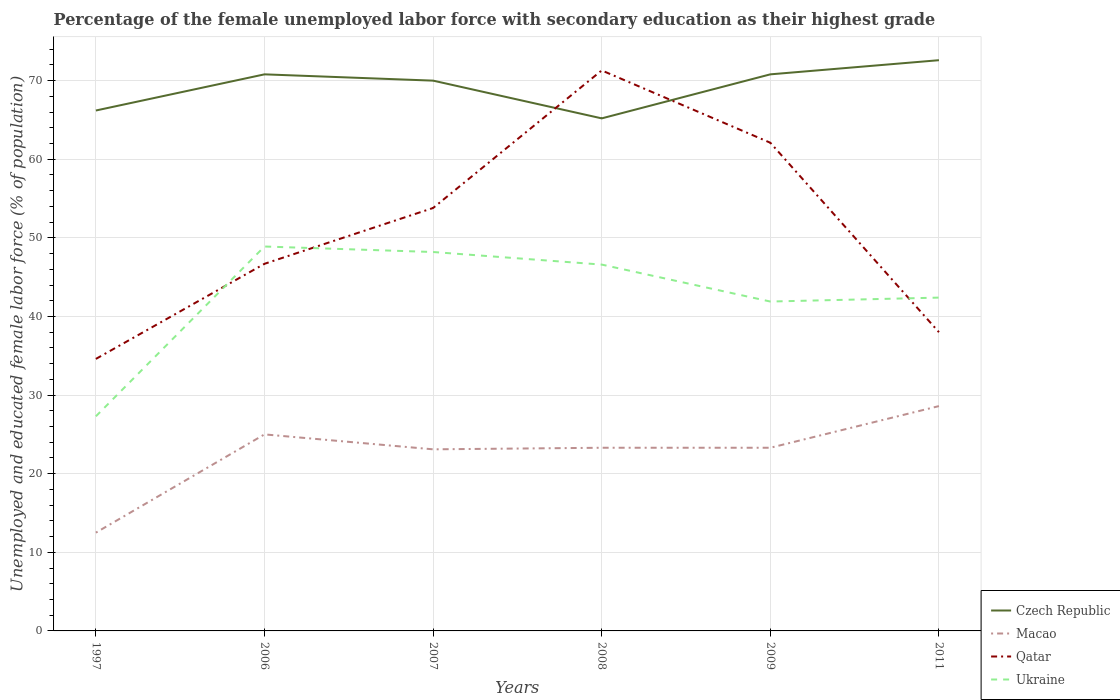In which year was the percentage of the unemployed female labor force with secondary education in Qatar maximum?
Ensure brevity in your answer.  1997. What is the total percentage of the unemployed female labor force with secondary education in Macao in the graph?
Ensure brevity in your answer.  -10.8. What is the difference between the highest and the second highest percentage of the unemployed female labor force with secondary education in Czech Republic?
Provide a short and direct response. 7.4. How many years are there in the graph?
Ensure brevity in your answer.  6. What is the difference between two consecutive major ticks on the Y-axis?
Your answer should be compact. 10. Does the graph contain any zero values?
Offer a very short reply. No. Does the graph contain grids?
Ensure brevity in your answer.  Yes. How many legend labels are there?
Offer a terse response. 4. How are the legend labels stacked?
Make the answer very short. Vertical. What is the title of the graph?
Offer a very short reply. Percentage of the female unemployed labor force with secondary education as their highest grade. Does "Arab World" appear as one of the legend labels in the graph?
Offer a terse response. No. What is the label or title of the X-axis?
Ensure brevity in your answer.  Years. What is the label or title of the Y-axis?
Ensure brevity in your answer.  Unemployed and educated female labor force (% of population). What is the Unemployed and educated female labor force (% of population) of Czech Republic in 1997?
Offer a very short reply. 66.2. What is the Unemployed and educated female labor force (% of population) in Qatar in 1997?
Ensure brevity in your answer.  34.6. What is the Unemployed and educated female labor force (% of population) of Ukraine in 1997?
Provide a short and direct response. 27.3. What is the Unemployed and educated female labor force (% of population) of Czech Republic in 2006?
Provide a short and direct response. 70.8. What is the Unemployed and educated female labor force (% of population) of Macao in 2006?
Provide a short and direct response. 25. What is the Unemployed and educated female labor force (% of population) in Qatar in 2006?
Make the answer very short. 46.7. What is the Unemployed and educated female labor force (% of population) of Ukraine in 2006?
Make the answer very short. 48.9. What is the Unemployed and educated female labor force (% of population) of Czech Republic in 2007?
Give a very brief answer. 70. What is the Unemployed and educated female labor force (% of population) in Macao in 2007?
Give a very brief answer. 23.1. What is the Unemployed and educated female labor force (% of population) of Qatar in 2007?
Your answer should be very brief. 53.8. What is the Unemployed and educated female labor force (% of population) in Ukraine in 2007?
Provide a short and direct response. 48.2. What is the Unemployed and educated female labor force (% of population) in Czech Republic in 2008?
Your response must be concise. 65.2. What is the Unemployed and educated female labor force (% of population) of Macao in 2008?
Offer a very short reply. 23.3. What is the Unemployed and educated female labor force (% of population) in Qatar in 2008?
Give a very brief answer. 71.3. What is the Unemployed and educated female labor force (% of population) in Ukraine in 2008?
Your answer should be compact. 46.6. What is the Unemployed and educated female labor force (% of population) in Czech Republic in 2009?
Provide a succinct answer. 70.8. What is the Unemployed and educated female labor force (% of population) of Macao in 2009?
Provide a succinct answer. 23.3. What is the Unemployed and educated female labor force (% of population) of Qatar in 2009?
Your answer should be compact. 62.1. What is the Unemployed and educated female labor force (% of population) in Ukraine in 2009?
Your answer should be very brief. 41.9. What is the Unemployed and educated female labor force (% of population) of Czech Republic in 2011?
Provide a short and direct response. 72.6. What is the Unemployed and educated female labor force (% of population) of Macao in 2011?
Offer a terse response. 28.6. What is the Unemployed and educated female labor force (% of population) of Ukraine in 2011?
Make the answer very short. 42.4. Across all years, what is the maximum Unemployed and educated female labor force (% of population) of Czech Republic?
Make the answer very short. 72.6. Across all years, what is the maximum Unemployed and educated female labor force (% of population) in Macao?
Offer a terse response. 28.6. Across all years, what is the maximum Unemployed and educated female labor force (% of population) of Qatar?
Ensure brevity in your answer.  71.3. Across all years, what is the maximum Unemployed and educated female labor force (% of population) in Ukraine?
Ensure brevity in your answer.  48.9. Across all years, what is the minimum Unemployed and educated female labor force (% of population) of Czech Republic?
Give a very brief answer. 65.2. Across all years, what is the minimum Unemployed and educated female labor force (% of population) of Qatar?
Give a very brief answer. 34.6. Across all years, what is the minimum Unemployed and educated female labor force (% of population) in Ukraine?
Keep it short and to the point. 27.3. What is the total Unemployed and educated female labor force (% of population) of Czech Republic in the graph?
Provide a succinct answer. 415.6. What is the total Unemployed and educated female labor force (% of population) in Macao in the graph?
Make the answer very short. 135.8. What is the total Unemployed and educated female labor force (% of population) in Qatar in the graph?
Keep it short and to the point. 306.5. What is the total Unemployed and educated female labor force (% of population) of Ukraine in the graph?
Your answer should be compact. 255.3. What is the difference between the Unemployed and educated female labor force (% of population) in Czech Republic in 1997 and that in 2006?
Your answer should be very brief. -4.6. What is the difference between the Unemployed and educated female labor force (% of population) of Macao in 1997 and that in 2006?
Offer a very short reply. -12.5. What is the difference between the Unemployed and educated female labor force (% of population) of Ukraine in 1997 and that in 2006?
Your answer should be compact. -21.6. What is the difference between the Unemployed and educated female labor force (% of population) in Qatar in 1997 and that in 2007?
Provide a succinct answer. -19.2. What is the difference between the Unemployed and educated female labor force (% of population) in Ukraine in 1997 and that in 2007?
Provide a short and direct response. -20.9. What is the difference between the Unemployed and educated female labor force (% of population) in Qatar in 1997 and that in 2008?
Your response must be concise. -36.7. What is the difference between the Unemployed and educated female labor force (% of population) in Ukraine in 1997 and that in 2008?
Give a very brief answer. -19.3. What is the difference between the Unemployed and educated female labor force (% of population) in Macao in 1997 and that in 2009?
Provide a short and direct response. -10.8. What is the difference between the Unemployed and educated female labor force (% of population) in Qatar in 1997 and that in 2009?
Your answer should be compact. -27.5. What is the difference between the Unemployed and educated female labor force (% of population) of Ukraine in 1997 and that in 2009?
Your answer should be very brief. -14.6. What is the difference between the Unemployed and educated female labor force (% of population) in Macao in 1997 and that in 2011?
Provide a short and direct response. -16.1. What is the difference between the Unemployed and educated female labor force (% of population) of Qatar in 1997 and that in 2011?
Keep it short and to the point. -3.4. What is the difference between the Unemployed and educated female labor force (% of population) in Ukraine in 1997 and that in 2011?
Offer a very short reply. -15.1. What is the difference between the Unemployed and educated female labor force (% of population) of Qatar in 2006 and that in 2007?
Your answer should be very brief. -7.1. What is the difference between the Unemployed and educated female labor force (% of population) in Macao in 2006 and that in 2008?
Your response must be concise. 1.7. What is the difference between the Unemployed and educated female labor force (% of population) of Qatar in 2006 and that in 2008?
Keep it short and to the point. -24.6. What is the difference between the Unemployed and educated female labor force (% of population) of Ukraine in 2006 and that in 2008?
Ensure brevity in your answer.  2.3. What is the difference between the Unemployed and educated female labor force (% of population) of Qatar in 2006 and that in 2009?
Offer a terse response. -15.4. What is the difference between the Unemployed and educated female labor force (% of population) in Ukraine in 2006 and that in 2011?
Your answer should be compact. 6.5. What is the difference between the Unemployed and educated female labor force (% of population) in Macao in 2007 and that in 2008?
Keep it short and to the point. -0.2. What is the difference between the Unemployed and educated female labor force (% of population) in Qatar in 2007 and that in 2008?
Provide a short and direct response. -17.5. What is the difference between the Unemployed and educated female labor force (% of population) of Macao in 2007 and that in 2011?
Offer a terse response. -5.5. What is the difference between the Unemployed and educated female labor force (% of population) of Ukraine in 2008 and that in 2009?
Ensure brevity in your answer.  4.7. What is the difference between the Unemployed and educated female labor force (% of population) of Czech Republic in 2008 and that in 2011?
Your answer should be compact. -7.4. What is the difference between the Unemployed and educated female labor force (% of population) in Macao in 2008 and that in 2011?
Keep it short and to the point. -5.3. What is the difference between the Unemployed and educated female labor force (% of population) of Qatar in 2008 and that in 2011?
Provide a short and direct response. 33.3. What is the difference between the Unemployed and educated female labor force (% of population) in Ukraine in 2008 and that in 2011?
Your response must be concise. 4.2. What is the difference between the Unemployed and educated female labor force (% of population) of Qatar in 2009 and that in 2011?
Offer a terse response. 24.1. What is the difference between the Unemployed and educated female labor force (% of population) of Czech Republic in 1997 and the Unemployed and educated female labor force (% of population) of Macao in 2006?
Ensure brevity in your answer.  41.2. What is the difference between the Unemployed and educated female labor force (% of population) of Czech Republic in 1997 and the Unemployed and educated female labor force (% of population) of Qatar in 2006?
Make the answer very short. 19.5. What is the difference between the Unemployed and educated female labor force (% of population) of Macao in 1997 and the Unemployed and educated female labor force (% of population) of Qatar in 2006?
Give a very brief answer. -34.2. What is the difference between the Unemployed and educated female labor force (% of population) in Macao in 1997 and the Unemployed and educated female labor force (% of population) in Ukraine in 2006?
Your response must be concise. -36.4. What is the difference between the Unemployed and educated female labor force (% of population) of Qatar in 1997 and the Unemployed and educated female labor force (% of population) of Ukraine in 2006?
Offer a terse response. -14.3. What is the difference between the Unemployed and educated female labor force (% of population) in Czech Republic in 1997 and the Unemployed and educated female labor force (% of population) in Macao in 2007?
Provide a succinct answer. 43.1. What is the difference between the Unemployed and educated female labor force (% of population) in Czech Republic in 1997 and the Unemployed and educated female labor force (% of population) in Ukraine in 2007?
Keep it short and to the point. 18. What is the difference between the Unemployed and educated female labor force (% of population) of Macao in 1997 and the Unemployed and educated female labor force (% of population) of Qatar in 2007?
Ensure brevity in your answer.  -41.3. What is the difference between the Unemployed and educated female labor force (% of population) in Macao in 1997 and the Unemployed and educated female labor force (% of population) in Ukraine in 2007?
Your answer should be very brief. -35.7. What is the difference between the Unemployed and educated female labor force (% of population) of Czech Republic in 1997 and the Unemployed and educated female labor force (% of population) of Macao in 2008?
Provide a succinct answer. 42.9. What is the difference between the Unemployed and educated female labor force (% of population) of Czech Republic in 1997 and the Unemployed and educated female labor force (% of population) of Qatar in 2008?
Provide a succinct answer. -5.1. What is the difference between the Unemployed and educated female labor force (% of population) of Czech Republic in 1997 and the Unemployed and educated female labor force (% of population) of Ukraine in 2008?
Offer a very short reply. 19.6. What is the difference between the Unemployed and educated female labor force (% of population) of Macao in 1997 and the Unemployed and educated female labor force (% of population) of Qatar in 2008?
Your answer should be very brief. -58.8. What is the difference between the Unemployed and educated female labor force (% of population) in Macao in 1997 and the Unemployed and educated female labor force (% of population) in Ukraine in 2008?
Your answer should be very brief. -34.1. What is the difference between the Unemployed and educated female labor force (% of population) in Czech Republic in 1997 and the Unemployed and educated female labor force (% of population) in Macao in 2009?
Offer a terse response. 42.9. What is the difference between the Unemployed and educated female labor force (% of population) in Czech Republic in 1997 and the Unemployed and educated female labor force (% of population) in Qatar in 2009?
Keep it short and to the point. 4.1. What is the difference between the Unemployed and educated female labor force (% of population) in Czech Republic in 1997 and the Unemployed and educated female labor force (% of population) in Ukraine in 2009?
Provide a short and direct response. 24.3. What is the difference between the Unemployed and educated female labor force (% of population) in Macao in 1997 and the Unemployed and educated female labor force (% of population) in Qatar in 2009?
Ensure brevity in your answer.  -49.6. What is the difference between the Unemployed and educated female labor force (% of population) in Macao in 1997 and the Unemployed and educated female labor force (% of population) in Ukraine in 2009?
Your answer should be very brief. -29.4. What is the difference between the Unemployed and educated female labor force (% of population) in Qatar in 1997 and the Unemployed and educated female labor force (% of population) in Ukraine in 2009?
Offer a terse response. -7.3. What is the difference between the Unemployed and educated female labor force (% of population) of Czech Republic in 1997 and the Unemployed and educated female labor force (% of population) of Macao in 2011?
Offer a terse response. 37.6. What is the difference between the Unemployed and educated female labor force (% of population) of Czech Republic in 1997 and the Unemployed and educated female labor force (% of population) of Qatar in 2011?
Offer a very short reply. 28.2. What is the difference between the Unemployed and educated female labor force (% of population) in Czech Republic in 1997 and the Unemployed and educated female labor force (% of population) in Ukraine in 2011?
Offer a terse response. 23.8. What is the difference between the Unemployed and educated female labor force (% of population) of Macao in 1997 and the Unemployed and educated female labor force (% of population) of Qatar in 2011?
Provide a succinct answer. -25.5. What is the difference between the Unemployed and educated female labor force (% of population) in Macao in 1997 and the Unemployed and educated female labor force (% of population) in Ukraine in 2011?
Offer a very short reply. -29.9. What is the difference between the Unemployed and educated female labor force (% of population) of Czech Republic in 2006 and the Unemployed and educated female labor force (% of population) of Macao in 2007?
Keep it short and to the point. 47.7. What is the difference between the Unemployed and educated female labor force (% of population) in Czech Republic in 2006 and the Unemployed and educated female labor force (% of population) in Qatar in 2007?
Ensure brevity in your answer.  17. What is the difference between the Unemployed and educated female labor force (% of population) in Czech Republic in 2006 and the Unemployed and educated female labor force (% of population) in Ukraine in 2007?
Offer a terse response. 22.6. What is the difference between the Unemployed and educated female labor force (% of population) of Macao in 2006 and the Unemployed and educated female labor force (% of population) of Qatar in 2007?
Provide a succinct answer. -28.8. What is the difference between the Unemployed and educated female labor force (% of population) of Macao in 2006 and the Unemployed and educated female labor force (% of population) of Ukraine in 2007?
Your answer should be compact. -23.2. What is the difference between the Unemployed and educated female labor force (% of population) in Qatar in 2006 and the Unemployed and educated female labor force (% of population) in Ukraine in 2007?
Ensure brevity in your answer.  -1.5. What is the difference between the Unemployed and educated female labor force (% of population) in Czech Republic in 2006 and the Unemployed and educated female labor force (% of population) in Macao in 2008?
Your answer should be compact. 47.5. What is the difference between the Unemployed and educated female labor force (% of population) in Czech Republic in 2006 and the Unemployed and educated female labor force (% of population) in Qatar in 2008?
Offer a very short reply. -0.5. What is the difference between the Unemployed and educated female labor force (% of population) in Czech Republic in 2006 and the Unemployed and educated female labor force (% of population) in Ukraine in 2008?
Ensure brevity in your answer.  24.2. What is the difference between the Unemployed and educated female labor force (% of population) of Macao in 2006 and the Unemployed and educated female labor force (% of population) of Qatar in 2008?
Offer a terse response. -46.3. What is the difference between the Unemployed and educated female labor force (% of population) of Macao in 2006 and the Unemployed and educated female labor force (% of population) of Ukraine in 2008?
Offer a terse response. -21.6. What is the difference between the Unemployed and educated female labor force (% of population) in Czech Republic in 2006 and the Unemployed and educated female labor force (% of population) in Macao in 2009?
Offer a very short reply. 47.5. What is the difference between the Unemployed and educated female labor force (% of population) of Czech Republic in 2006 and the Unemployed and educated female labor force (% of population) of Qatar in 2009?
Your response must be concise. 8.7. What is the difference between the Unemployed and educated female labor force (% of population) of Czech Republic in 2006 and the Unemployed and educated female labor force (% of population) of Ukraine in 2009?
Give a very brief answer. 28.9. What is the difference between the Unemployed and educated female labor force (% of population) in Macao in 2006 and the Unemployed and educated female labor force (% of population) in Qatar in 2009?
Provide a succinct answer. -37.1. What is the difference between the Unemployed and educated female labor force (% of population) in Macao in 2006 and the Unemployed and educated female labor force (% of population) in Ukraine in 2009?
Make the answer very short. -16.9. What is the difference between the Unemployed and educated female labor force (% of population) of Czech Republic in 2006 and the Unemployed and educated female labor force (% of population) of Macao in 2011?
Your answer should be compact. 42.2. What is the difference between the Unemployed and educated female labor force (% of population) in Czech Republic in 2006 and the Unemployed and educated female labor force (% of population) in Qatar in 2011?
Keep it short and to the point. 32.8. What is the difference between the Unemployed and educated female labor force (% of population) of Czech Republic in 2006 and the Unemployed and educated female labor force (% of population) of Ukraine in 2011?
Offer a terse response. 28.4. What is the difference between the Unemployed and educated female labor force (% of population) of Macao in 2006 and the Unemployed and educated female labor force (% of population) of Ukraine in 2011?
Make the answer very short. -17.4. What is the difference between the Unemployed and educated female labor force (% of population) in Qatar in 2006 and the Unemployed and educated female labor force (% of population) in Ukraine in 2011?
Your answer should be compact. 4.3. What is the difference between the Unemployed and educated female labor force (% of population) of Czech Republic in 2007 and the Unemployed and educated female labor force (% of population) of Macao in 2008?
Your answer should be very brief. 46.7. What is the difference between the Unemployed and educated female labor force (% of population) in Czech Republic in 2007 and the Unemployed and educated female labor force (% of population) in Ukraine in 2008?
Provide a short and direct response. 23.4. What is the difference between the Unemployed and educated female labor force (% of population) of Macao in 2007 and the Unemployed and educated female labor force (% of population) of Qatar in 2008?
Your response must be concise. -48.2. What is the difference between the Unemployed and educated female labor force (% of population) in Macao in 2007 and the Unemployed and educated female labor force (% of population) in Ukraine in 2008?
Your answer should be compact. -23.5. What is the difference between the Unemployed and educated female labor force (% of population) of Czech Republic in 2007 and the Unemployed and educated female labor force (% of population) of Macao in 2009?
Your response must be concise. 46.7. What is the difference between the Unemployed and educated female labor force (% of population) of Czech Republic in 2007 and the Unemployed and educated female labor force (% of population) of Qatar in 2009?
Ensure brevity in your answer.  7.9. What is the difference between the Unemployed and educated female labor force (% of population) in Czech Republic in 2007 and the Unemployed and educated female labor force (% of population) in Ukraine in 2009?
Make the answer very short. 28.1. What is the difference between the Unemployed and educated female labor force (% of population) of Macao in 2007 and the Unemployed and educated female labor force (% of population) of Qatar in 2009?
Offer a terse response. -39. What is the difference between the Unemployed and educated female labor force (% of population) of Macao in 2007 and the Unemployed and educated female labor force (% of population) of Ukraine in 2009?
Offer a very short reply. -18.8. What is the difference between the Unemployed and educated female labor force (% of population) of Czech Republic in 2007 and the Unemployed and educated female labor force (% of population) of Macao in 2011?
Keep it short and to the point. 41.4. What is the difference between the Unemployed and educated female labor force (% of population) of Czech Republic in 2007 and the Unemployed and educated female labor force (% of population) of Ukraine in 2011?
Offer a terse response. 27.6. What is the difference between the Unemployed and educated female labor force (% of population) of Macao in 2007 and the Unemployed and educated female labor force (% of population) of Qatar in 2011?
Give a very brief answer. -14.9. What is the difference between the Unemployed and educated female labor force (% of population) of Macao in 2007 and the Unemployed and educated female labor force (% of population) of Ukraine in 2011?
Keep it short and to the point. -19.3. What is the difference between the Unemployed and educated female labor force (% of population) in Czech Republic in 2008 and the Unemployed and educated female labor force (% of population) in Macao in 2009?
Keep it short and to the point. 41.9. What is the difference between the Unemployed and educated female labor force (% of population) of Czech Republic in 2008 and the Unemployed and educated female labor force (% of population) of Ukraine in 2009?
Your response must be concise. 23.3. What is the difference between the Unemployed and educated female labor force (% of population) of Macao in 2008 and the Unemployed and educated female labor force (% of population) of Qatar in 2009?
Provide a short and direct response. -38.8. What is the difference between the Unemployed and educated female labor force (% of population) in Macao in 2008 and the Unemployed and educated female labor force (% of population) in Ukraine in 2009?
Your response must be concise. -18.6. What is the difference between the Unemployed and educated female labor force (% of population) of Qatar in 2008 and the Unemployed and educated female labor force (% of population) of Ukraine in 2009?
Keep it short and to the point. 29.4. What is the difference between the Unemployed and educated female labor force (% of population) in Czech Republic in 2008 and the Unemployed and educated female labor force (% of population) in Macao in 2011?
Your answer should be compact. 36.6. What is the difference between the Unemployed and educated female labor force (% of population) of Czech Republic in 2008 and the Unemployed and educated female labor force (% of population) of Qatar in 2011?
Provide a short and direct response. 27.2. What is the difference between the Unemployed and educated female labor force (% of population) of Czech Republic in 2008 and the Unemployed and educated female labor force (% of population) of Ukraine in 2011?
Keep it short and to the point. 22.8. What is the difference between the Unemployed and educated female labor force (% of population) of Macao in 2008 and the Unemployed and educated female labor force (% of population) of Qatar in 2011?
Ensure brevity in your answer.  -14.7. What is the difference between the Unemployed and educated female labor force (% of population) of Macao in 2008 and the Unemployed and educated female labor force (% of population) of Ukraine in 2011?
Offer a terse response. -19.1. What is the difference between the Unemployed and educated female labor force (% of population) of Qatar in 2008 and the Unemployed and educated female labor force (% of population) of Ukraine in 2011?
Your response must be concise. 28.9. What is the difference between the Unemployed and educated female labor force (% of population) in Czech Republic in 2009 and the Unemployed and educated female labor force (% of population) in Macao in 2011?
Provide a short and direct response. 42.2. What is the difference between the Unemployed and educated female labor force (% of population) in Czech Republic in 2009 and the Unemployed and educated female labor force (% of population) in Qatar in 2011?
Your answer should be compact. 32.8. What is the difference between the Unemployed and educated female labor force (% of population) in Czech Republic in 2009 and the Unemployed and educated female labor force (% of population) in Ukraine in 2011?
Offer a terse response. 28.4. What is the difference between the Unemployed and educated female labor force (% of population) of Macao in 2009 and the Unemployed and educated female labor force (% of population) of Qatar in 2011?
Keep it short and to the point. -14.7. What is the difference between the Unemployed and educated female labor force (% of population) of Macao in 2009 and the Unemployed and educated female labor force (% of population) of Ukraine in 2011?
Your answer should be very brief. -19.1. What is the average Unemployed and educated female labor force (% of population) in Czech Republic per year?
Your answer should be compact. 69.27. What is the average Unemployed and educated female labor force (% of population) of Macao per year?
Your answer should be very brief. 22.63. What is the average Unemployed and educated female labor force (% of population) of Qatar per year?
Keep it short and to the point. 51.08. What is the average Unemployed and educated female labor force (% of population) of Ukraine per year?
Provide a short and direct response. 42.55. In the year 1997, what is the difference between the Unemployed and educated female labor force (% of population) in Czech Republic and Unemployed and educated female labor force (% of population) in Macao?
Provide a short and direct response. 53.7. In the year 1997, what is the difference between the Unemployed and educated female labor force (% of population) of Czech Republic and Unemployed and educated female labor force (% of population) of Qatar?
Give a very brief answer. 31.6. In the year 1997, what is the difference between the Unemployed and educated female labor force (% of population) of Czech Republic and Unemployed and educated female labor force (% of population) of Ukraine?
Offer a terse response. 38.9. In the year 1997, what is the difference between the Unemployed and educated female labor force (% of population) of Macao and Unemployed and educated female labor force (% of population) of Qatar?
Provide a succinct answer. -22.1. In the year 1997, what is the difference between the Unemployed and educated female labor force (% of population) in Macao and Unemployed and educated female labor force (% of population) in Ukraine?
Provide a succinct answer. -14.8. In the year 2006, what is the difference between the Unemployed and educated female labor force (% of population) in Czech Republic and Unemployed and educated female labor force (% of population) in Macao?
Provide a succinct answer. 45.8. In the year 2006, what is the difference between the Unemployed and educated female labor force (% of population) in Czech Republic and Unemployed and educated female labor force (% of population) in Qatar?
Offer a very short reply. 24.1. In the year 2006, what is the difference between the Unemployed and educated female labor force (% of population) of Czech Republic and Unemployed and educated female labor force (% of population) of Ukraine?
Offer a terse response. 21.9. In the year 2006, what is the difference between the Unemployed and educated female labor force (% of population) in Macao and Unemployed and educated female labor force (% of population) in Qatar?
Your answer should be very brief. -21.7. In the year 2006, what is the difference between the Unemployed and educated female labor force (% of population) in Macao and Unemployed and educated female labor force (% of population) in Ukraine?
Provide a succinct answer. -23.9. In the year 2007, what is the difference between the Unemployed and educated female labor force (% of population) in Czech Republic and Unemployed and educated female labor force (% of population) in Macao?
Provide a short and direct response. 46.9. In the year 2007, what is the difference between the Unemployed and educated female labor force (% of population) in Czech Republic and Unemployed and educated female labor force (% of population) in Ukraine?
Provide a succinct answer. 21.8. In the year 2007, what is the difference between the Unemployed and educated female labor force (% of population) in Macao and Unemployed and educated female labor force (% of population) in Qatar?
Your answer should be compact. -30.7. In the year 2007, what is the difference between the Unemployed and educated female labor force (% of population) of Macao and Unemployed and educated female labor force (% of population) of Ukraine?
Offer a terse response. -25.1. In the year 2008, what is the difference between the Unemployed and educated female labor force (% of population) in Czech Republic and Unemployed and educated female labor force (% of population) in Macao?
Offer a very short reply. 41.9. In the year 2008, what is the difference between the Unemployed and educated female labor force (% of population) in Czech Republic and Unemployed and educated female labor force (% of population) in Qatar?
Give a very brief answer. -6.1. In the year 2008, what is the difference between the Unemployed and educated female labor force (% of population) of Czech Republic and Unemployed and educated female labor force (% of population) of Ukraine?
Your response must be concise. 18.6. In the year 2008, what is the difference between the Unemployed and educated female labor force (% of population) of Macao and Unemployed and educated female labor force (% of population) of Qatar?
Make the answer very short. -48. In the year 2008, what is the difference between the Unemployed and educated female labor force (% of population) of Macao and Unemployed and educated female labor force (% of population) of Ukraine?
Offer a terse response. -23.3. In the year 2008, what is the difference between the Unemployed and educated female labor force (% of population) in Qatar and Unemployed and educated female labor force (% of population) in Ukraine?
Ensure brevity in your answer.  24.7. In the year 2009, what is the difference between the Unemployed and educated female labor force (% of population) in Czech Republic and Unemployed and educated female labor force (% of population) in Macao?
Provide a succinct answer. 47.5. In the year 2009, what is the difference between the Unemployed and educated female labor force (% of population) in Czech Republic and Unemployed and educated female labor force (% of population) in Ukraine?
Provide a succinct answer. 28.9. In the year 2009, what is the difference between the Unemployed and educated female labor force (% of population) of Macao and Unemployed and educated female labor force (% of population) of Qatar?
Your answer should be very brief. -38.8. In the year 2009, what is the difference between the Unemployed and educated female labor force (% of population) in Macao and Unemployed and educated female labor force (% of population) in Ukraine?
Give a very brief answer. -18.6. In the year 2009, what is the difference between the Unemployed and educated female labor force (% of population) of Qatar and Unemployed and educated female labor force (% of population) of Ukraine?
Offer a very short reply. 20.2. In the year 2011, what is the difference between the Unemployed and educated female labor force (% of population) of Czech Republic and Unemployed and educated female labor force (% of population) of Macao?
Your response must be concise. 44. In the year 2011, what is the difference between the Unemployed and educated female labor force (% of population) in Czech Republic and Unemployed and educated female labor force (% of population) in Qatar?
Ensure brevity in your answer.  34.6. In the year 2011, what is the difference between the Unemployed and educated female labor force (% of population) in Czech Republic and Unemployed and educated female labor force (% of population) in Ukraine?
Provide a short and direct response. 30.2. In the year 2011, what is the difference between the Unemployed and educated female labor force (% of population) in Macao and Unemployed and educated female labor force (% of population) in Ukraine?
Your answer should be compact. -13.8. In the year 2011, what is the difference between the Unemployed and educated female labor force (% of population) of Qatar and Unemployed and educated female labor force (% of population) of Ukraine?
Your answer should be compact. -4.4. What is the ratio of the Unemployed and educated female labor force (% of population) of Czech Republic in 1997 to that in 2006?
Provide a short and direct response. 0.94. What is the ratio of the Unemployed and educated female labor force (% of population) of Macao in 1997 to that in 2006?
Make the answer very short. 0.5. What is the ratio of the Unemployed and educated female labor force (% of population) of Qatar in 1997 to that in 2006?
Offer a very short reply. 0.74. What is the ratio of the Unemployed and educated female labor force (% of population) in Ukraine in 1997 to that in 2006?
Offer a terse response. 0.56. What is the ratio of the Unemployed and educated female labor force (% of population) in Czech Republic in 1997 to that in 2007?
Provide a short and direct response. 0.95. What is the ratio of the Unemployed and educated female labor force (% of population) of Macao in 1997 to that in 2007?
Offer a terse response. 0.54. What is the ratio of the Unemployed and educated female labor force (% of population) of Qatar in 1997 to that in 2007?
Ensure brevity in your answer.  0.64. What is the ratio of the Unemployed and educated female labor force (% of population) in Ukraine in 1997 to that in 2007?
Offer a terse response. 0.57. What is the ratio of the Unemployed and educated female labor force (% of population) in Czech Republic in 1997 to that in 2008?
Give a very brief answer. 1.02. What is the ratio of the Unemployed and educated female labor force (% of population) in Macao in 1997 to that in 2008?
Make the answer very short. 0.54. What is the ratio of the Unemployed and educated female labor force (% of population) in Qatar in 1997 to that in 2008?
Your answer should be very brief. 0.49. What is the ratio of the Unemployed and educated female labor force (% of population) in Ukraine in 1997 to that in 2008?
Offer a terse response. 0.59. What is the ratio of the Unemployed and educated female labor force (% of population) in Czech Republic in 1997 to that in 2009?
Provide a short and direct response. 0.94. What is the ratio of the Unemployed and educated female labor force (% of population) of Macao in 1997 to that in 2009?
Keep it short and to the point. 0.54. What is the ratio of the Unemployed and educated female labor force (% of population) in Qatar in 1997 to that in 2009?
Offer a very short reply. 0.56. What is the ratio of the Unemployed and educated female labor force (% of population) in Ukraine in 1997 to that in 2009?
Your answer should be compact. 0.65. What is the ratio of the Unemployed and educated female labor force (% of population) in Czech Republic in 1997 to that in 2011?
Make the answer very short. 0.91. What is the ratio of the Unemployed and educated female labor force (% of population) in Macao in 1997 to that in 2011?
Offer a terse response. 0.44. What is the ratio of the Unemployed and educated female labor force (% of population) of Qatar in 1997 to that in 2011?
Keep it short and to the point. 0.91. What is the ratio of the Unemployed and educated female labor force (% of population) in Ukraine in 1997 to that in 2011?
Keep it short and to the point. 0.64. What is the ratio of the Unemployed and educated female labor force (% of population) of Czech Republic in 2006 to that in 2007?
Provide a succinct answer. 1.01. What is the ratio of the Unemployed and educated female labor force (% of population) in Macao in 2006 to that in 2007?
Provide a short and direct response. 1.08. What is the ratio of the Unemployed and educated female labor force (% of population) in Qatar in 2006 to that in 2007?
Your response must be concise. 0.87. What is the ratio of the Unemployed and educated female labor force (% of population) in Ukraine in 2006 to that in 2007?
Provide a short and direct response. 1.01. What is the ratio of the Unemployed and educated female labor force (% of population) in Czech Republic in 2006 to that in 2008?
Provide a succinct answer. 1.09. What is the ratio of the Unemployed and educated female labor force (% of population) in Macao in 2006 to that in 2008?
Offer a terse response. 1.07. What is the ratio of the Unemployed and educated female labor force (% of population) of Qatar in 2006 to that in 2008?
Give a very brief answer. 0.66. What is the ratio of the Unemployed and educated female labor force (% of population) of Ukraine in 2006 to that in 2008?
Make the answer very short. 1.05. What is the ratio of the Unemployed and educated female labor force (% of population) in Macao in 2006 to that in 2009?
Your answer should be compact. 1.07. What is the ratio of the Unemployed and educated female labor force (% of population) in Qatar in 2006 to that in 2009?
Your answer should be compact. 0.75. What is the ratio of the Unemployed and educated female labor force (% of population) of Ukraine in 2006 to that in 2009?
Give a very brief answer. 1.17. What is the ratio of the Unemployed and educated female labor force (% of population) in Czech Republic in 2006 to that in 2011?
Your answer should be very brief. 0.98. What is the ratio of the Unemployed and educated female labor force (% of population) of Macao in 2006 to that in 2011?
Ensure brevity in your answer.  0.87. What is the ratio of the Unemployed and educated female labor force (% of population) in Qatar in 2006 to that in 2011?
Make the answer very short. 1.23. What is the ratio of the Unemployed and educated female labor force (% of population) in Ukraine in 2006 to that in 2011?
Provide a succinct answer. 1.15. What is the ratio of the Unemployed and educated female labor force (% of population) of Czech Republic in 2007 to that in 2008?
Keep it short and to the point. 1.07. What is the ratio of the Unemployed and educated female labor force (% of population) in Macao in 2007 to that in 2008?
Offer a very short reply. 0.99. What is the ratio of the Unemployed and educated female labor force (% of population) in Qatar in 2007 to that in 2008?
Give a very brief answer. 0.75. What is the ratio of the Unemployed and educated female labor force (% of population) of Ukraine in 2007 to that in 2008?
Give a very brief answer. 1.03. What is the ratio of the Unemployed and educated female labor force (% of population) of Czech Republic in 2007 to that in 2009?
Your response must be concise. 0.99. What is the ratio of the Unemployed and educated female labor force (% of population) in Macao in 2007 to that in 2009?
Provide a succinct answer. 0.99. What is the ratio of the Unemployed and educated female labor force (% of population) in Qatar in 2007 to that in 2009?
Your response must be concise. 0.87. What is the ratio of the Unemployed and educated female labor force (% of population) of Ukraine in 2007 to that in 2009?
Offer a terse response. 1.15. What is the ratio of the Unemployed and educated female labor force (% of population) in Czech Republic in 2007 to that in 2011?
Make the answer very short. 0.96. What is the ratio of the Unemployed and educated female labor force (% of population) of Macao in 2007 to that in 2011?
Your answer should be very brief. 0.81. What is the ratio of the Unemployed and educated female labor force (% of population) in Qatar in 2007 to that in 2011?
Provide a succinct answer. 1.42. What is the ratio of the Unemployed and educated female labor force (% of population) of Ukraine in 2007 to that in 2011?
Keep it short and to the point. 1.14. What is the ratio of the Unemployed and educated female labor force (% of population) of Czech Republic in 2008 to that in 2009?
Provide a succinct answer. 0.92. What is the ratio of the Unemployed and educated female labor force (% of population) in Qatar in 2008 to that in 2009?
Offer a terse response. 1.15. What is the ratio of the Unemployed and educated female labor force (% of population) of Ukraine in 2008 to that in 2009?
Your answer should be very brief. 1.11. What is the ratio of the Unemployed and educated female labor force (% of population) in Czech Republic in 2008 to that in 2011?
Your response must be concise. 0.9. What is the ratio of the Unemployed and educated female labor force (% of population) in Macao in 2008 to that in 2011?
Keep it short and to the point. 0.81. What is the ratio of the Unemployed and educated female labor force (% of population) in Qatar in 2008 to that in 2011?
Ensure brevity in your answer.  1.88. What is the ratio of the Unemployed and educated female labor force (% of population) in Ukraine in 2008 to that in 2011?
Offer a very short reply. 1.1. What is the ratio of the Unemployed and educated female labor force (% of population) of Czech Republic in 2009 to that in 2011?
Give a very brief answer. 0.98. What is the ratio of the Unemployed and educated female labor force (% of population) in Macao in 2009 to that in 2011?
Keep it short and to the point. 0.81. What is the ratio of the Unemployed and educated female labor force (% of population) of Qatar in 2009 to that in 2011?
Keep it short and to the point. 1.63. What is the difference between the highest and the second highest Unemployed and educated female labor force (% of population) of Qatar?
Give a very brief answer. 9.2. What is the difference between the highest and the second highest Unemployed and educated female labor force (% of population) in Ukraine?
Ensure brevity in your answer.  0.7. What is the difference between the highest and the lowest Unemployed and educated female labor force (% of population) of Macao?
Ensure brevity in your answer.  16.1. What is the difference between the highest and the lowest Unemployed and educated female labor force (% of population) of Qatar?
Your response must be concise. 36.7. What is the difference between the highest and the lowest Unemployed and educated female labor force (% of population) in Ukraine?
Provide a short and direct response. 21.6. 